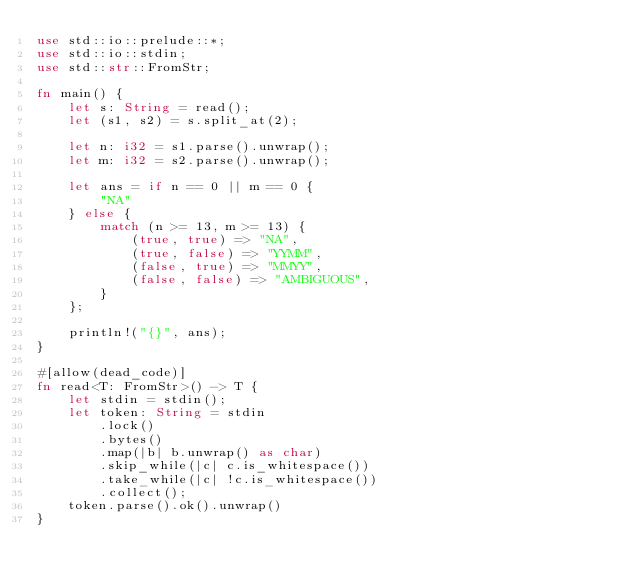Convert code to text. <code><loc_0><loc_0><loc_500><loc_500><_Rust_>use std::io::prelude::*;
use std::io::stdin;
use std::str::FromStr;

fn main() {
    let s: String = read();
    let (s1, s2) = s.split_at(2);

    let n: i32 = s1.parse().unwrap();
    let m: i32 = s2.parse().unwrap();

    let ans = if n == 0 || m == 0 {
        "NA"
    } else {
        match (n >= 13, m >= 13) {
            (true, true) => "NA",
            (true, false) => "YYMM",
            (false, true) => "MMYY",
            (false, false) => "AMBIGUOUS",
        }
    };

    println!("{}", ans);
}

#[allow(dead_code)]
fn read<T: FromStr>() -> T {
    let stdin = stdin();
    let token: String = stdin
        .lock()
        .bytes()
        .map(|b| b.unwrap() as char)
        .skip_while(|c| c.is_whitespace())
        .take_while(|c| !c.is_whitespace())
        .collect();
    token.parse().ok().unwrap()
}
</code> 